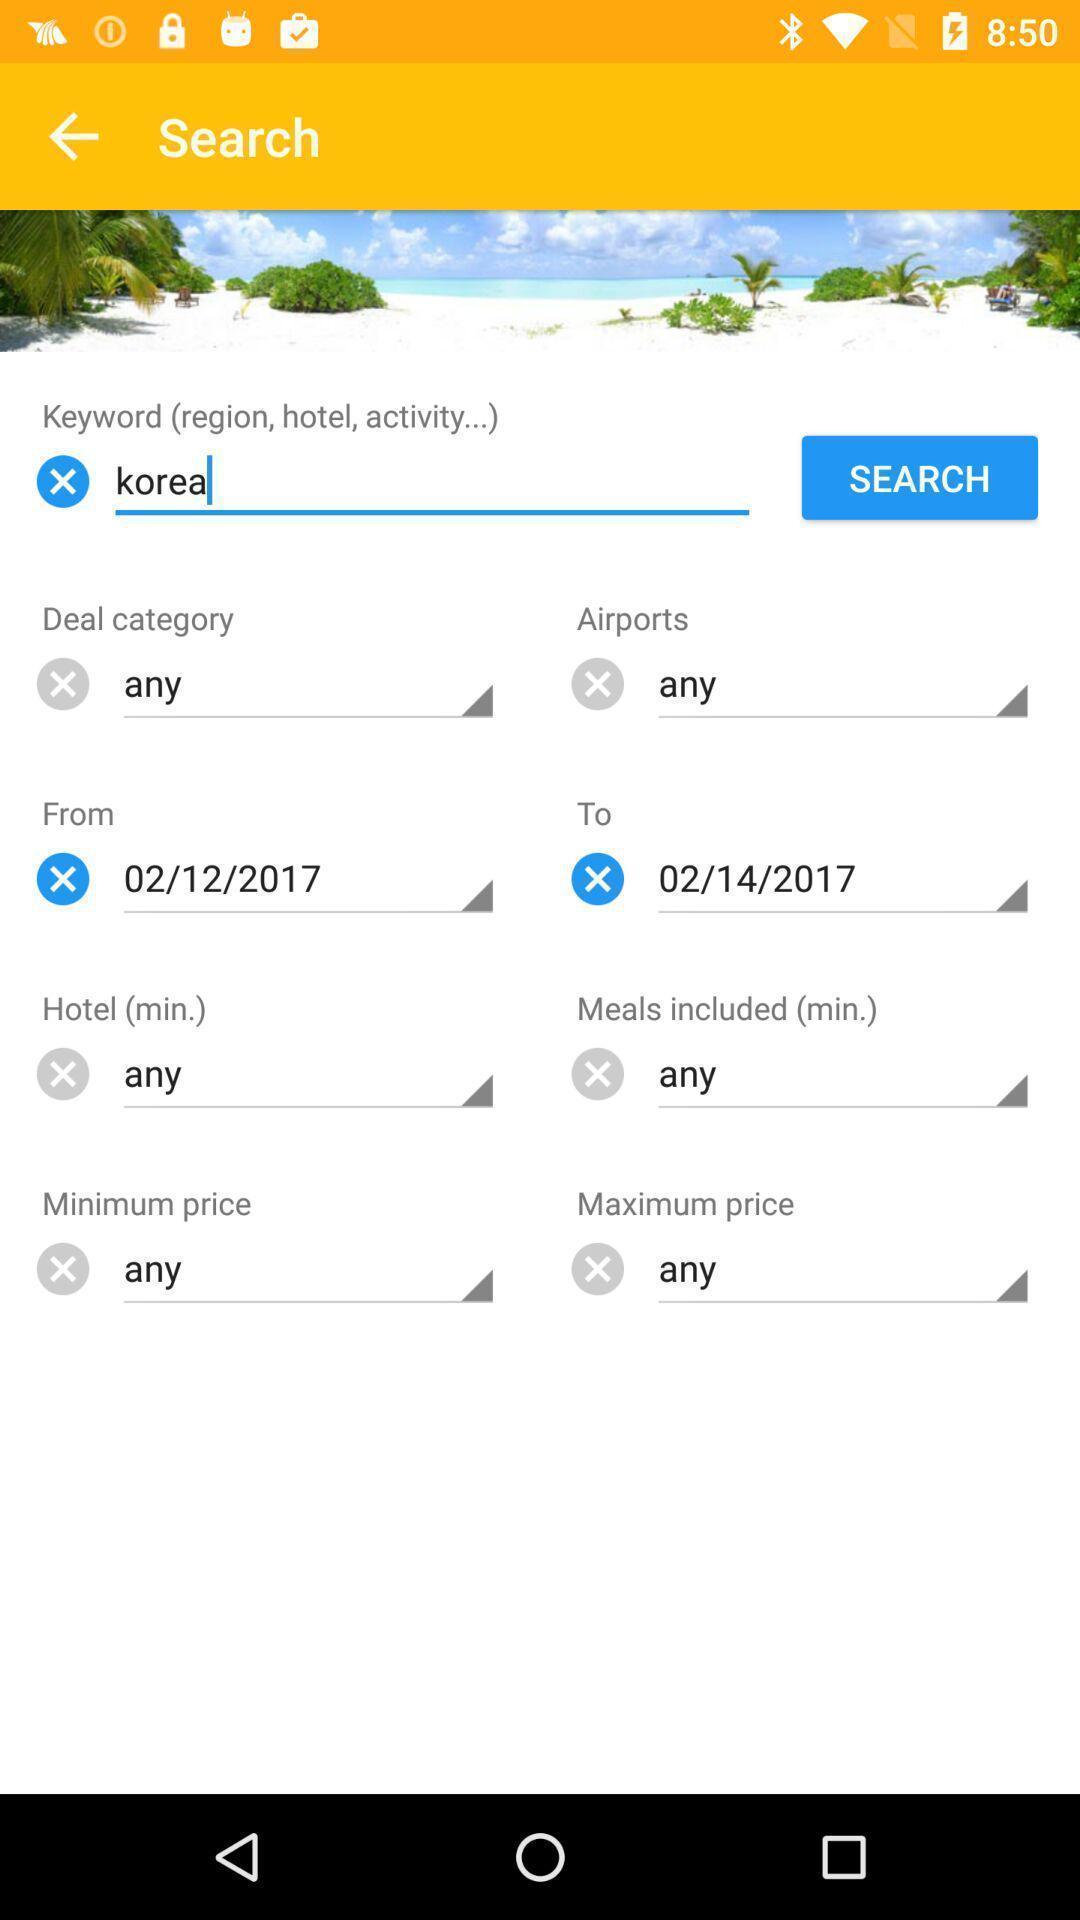Explain the elements present in this screenshot. Search bar to find hotels airports with prices. 